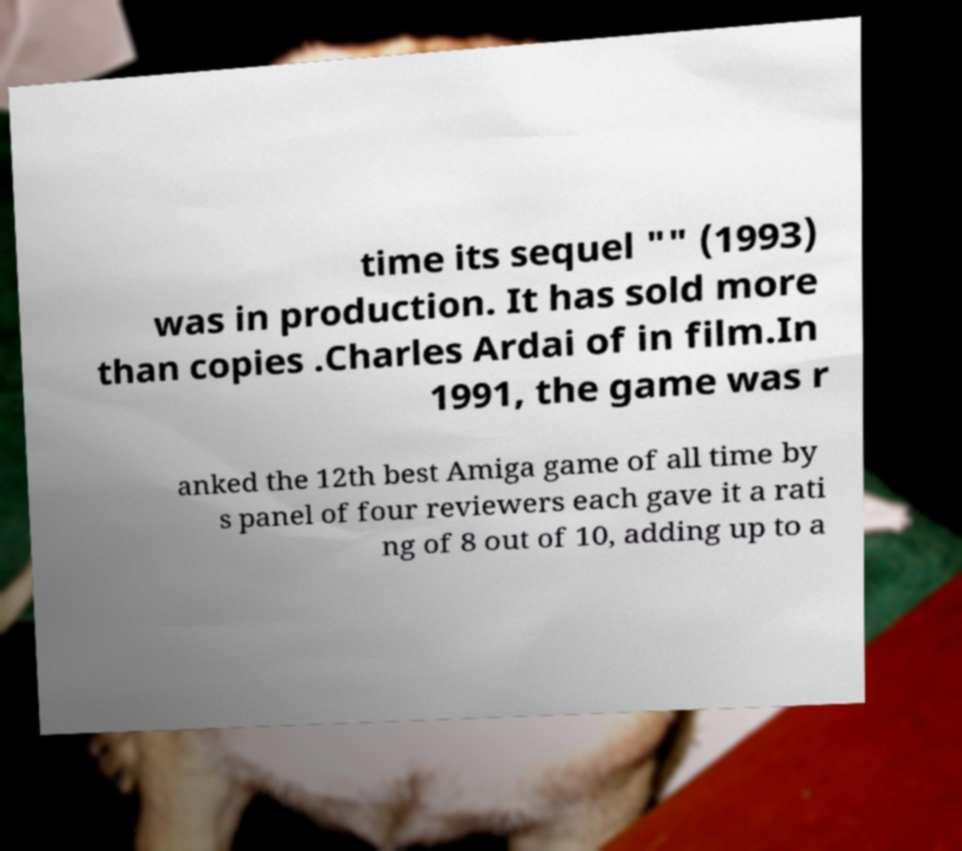There's text embedded in this image that I need extracted. Can you transcribe it verbatim? time its sequel "" (1993) was in production. It has sold more than copies .Charles Ardai of in film.In 1991, the game was r anked the 12th best Amiga game of all time by s panel of four reviewers each gave it a rati ng of 8 out of 10, adding up to a 